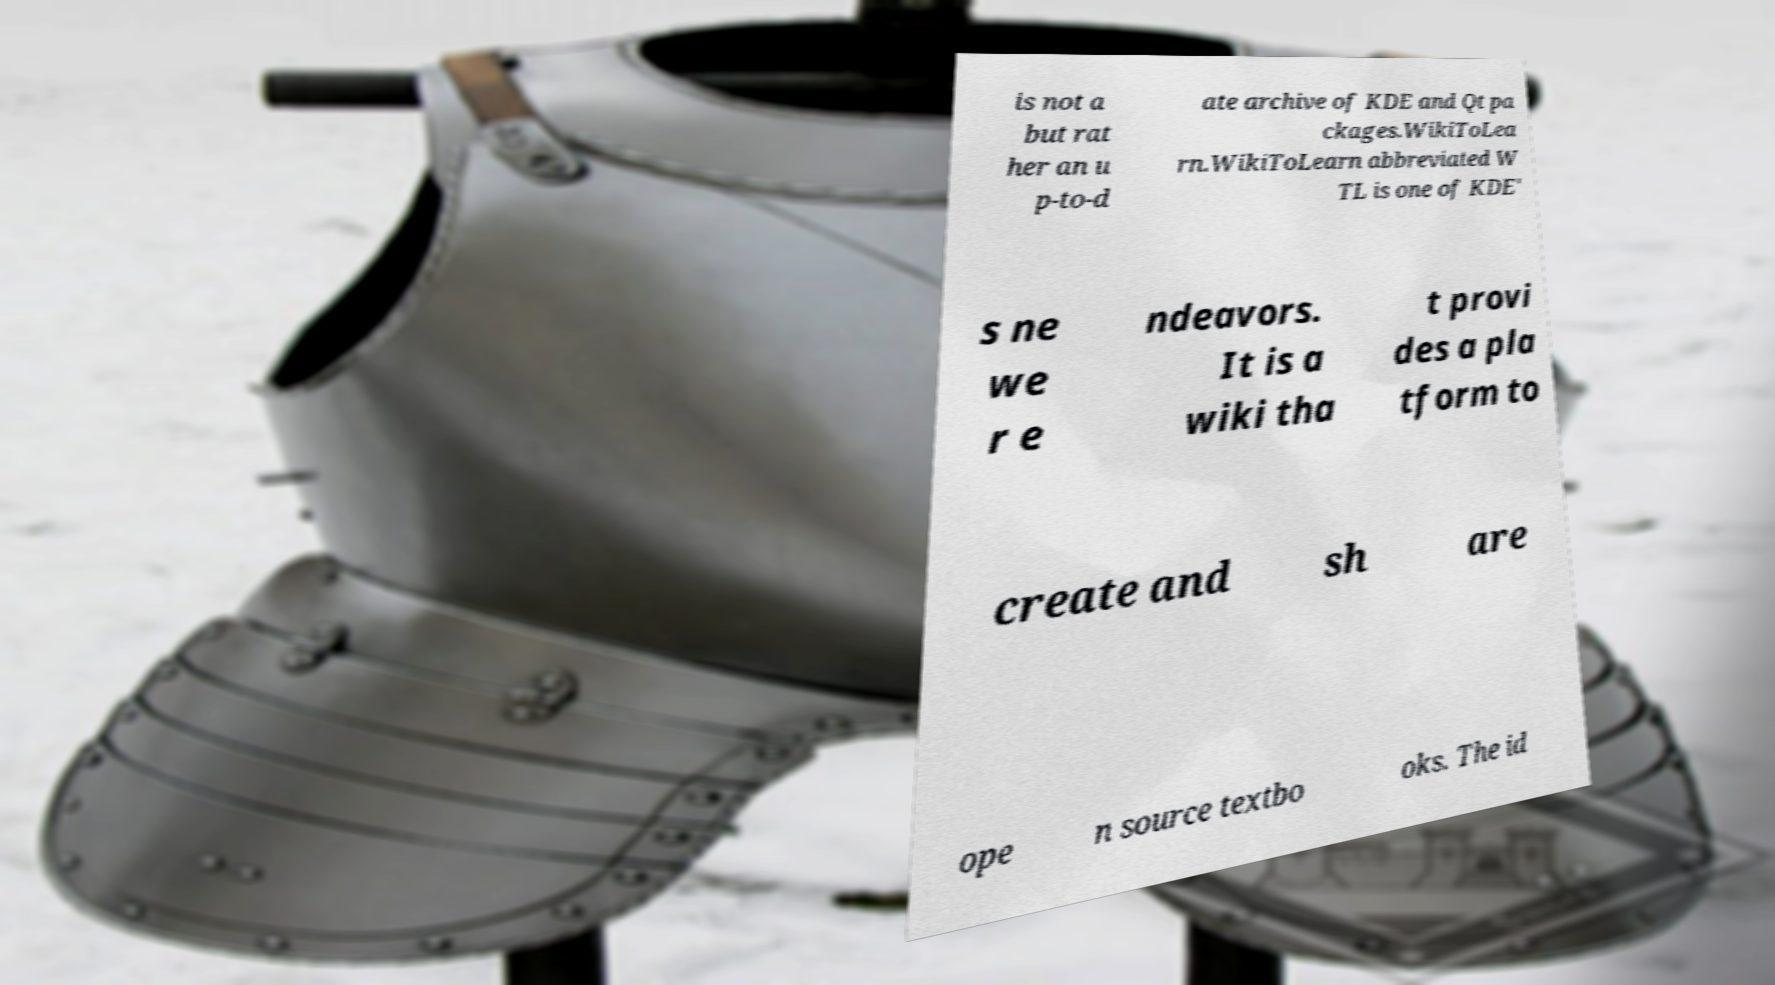Can you read and provide the text displayed in the image?This photo seems to have some interesting text. Can you extract and type it out for me? is not a but rat her an u p-to-d ate archive of KDE and Qt pa ckages.WikiToLea rn.WikiToLearn abbreviated W TL is one of KDE' s ne we r e ndeavors. It is a wiki tha t provi des a pla tform to create and sh are ope n source textbo oks. The id 